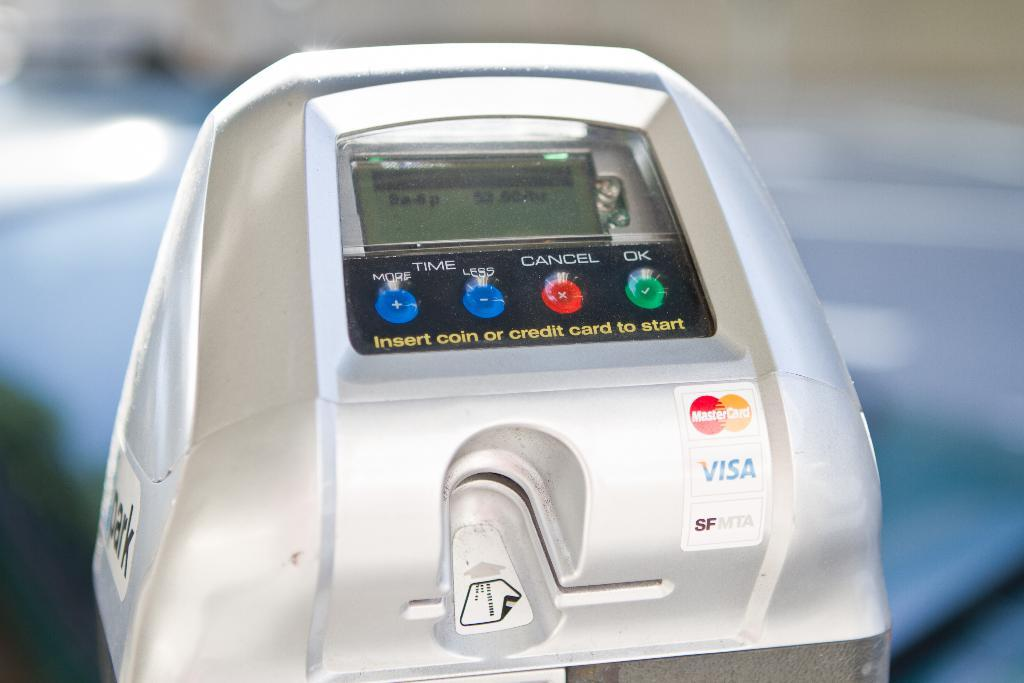<image>
Relay a brief, clear account of the picture shown. a machine that accepts both MasterCard and Visa 